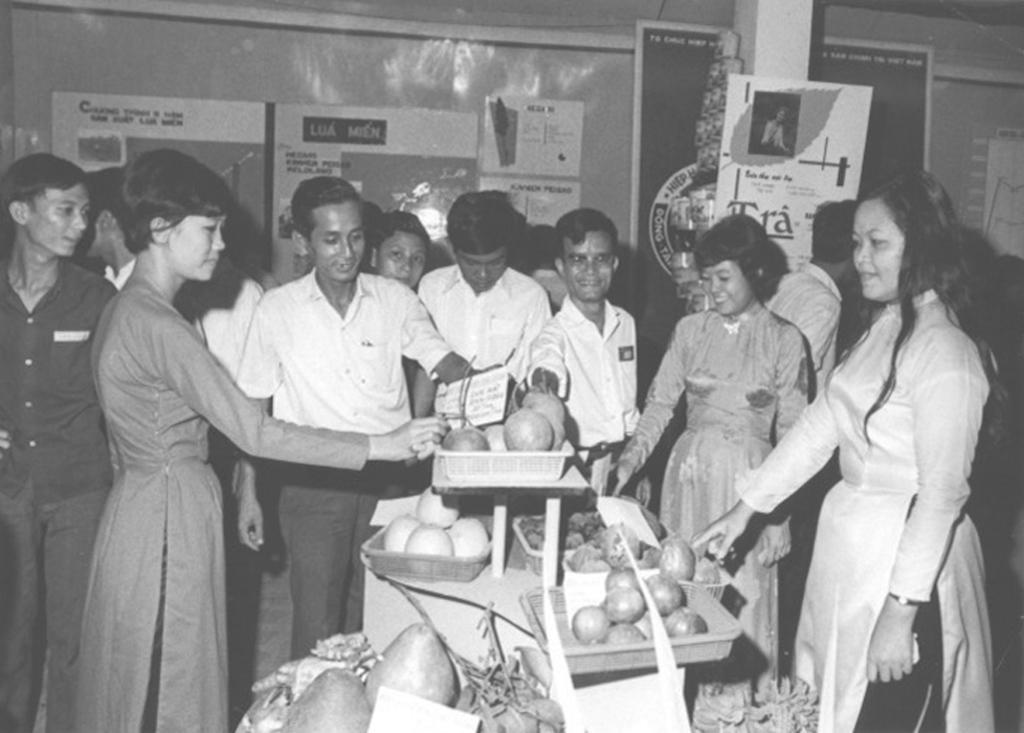Please provide a concise description of this image. In the image we can see there are people standing and there are fruits and vegetables kept in the basket. Behind there are banners on the wall and the image is in black and white colour. 